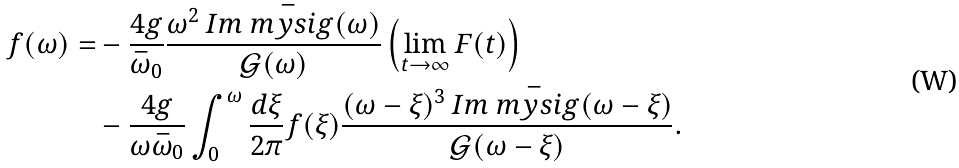<formula> <loc_0><loc_0><loc_500><loc_500>f ( \omega ) = & - \frac { 4 g } { \bar { \omega } _ { 0 } } \frac { \omega ^ { 2 } \, I m \bar { \ m y s i g } ( \omega ) } { \mathcal { G } ( \omega ) } \left ( \lim _ { t \rightarrow \infty } F ( t ) \right ) \\ & - \frac { 4 g } { \omega \bar { \omega } _ { 0 } } \int _ { 0 } ^ { \omega } \frac { d \xi } { 2 \pi } f ( \xi ) \frac { ( \omega - \xi ) ^ { 3 } \, I m \bar { \ m y s i g } ( \omega - \xi ) } { \mathcal { G } ( \omega - \xi ) } .</formula> 